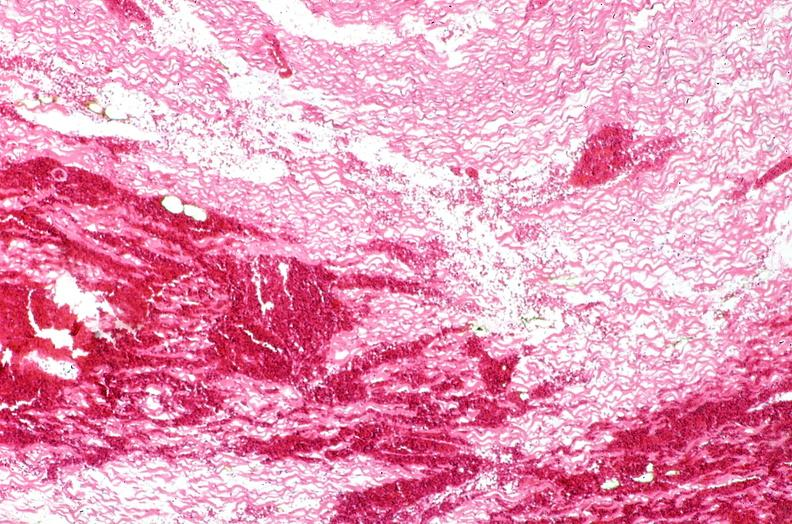what is present?
Answer the question using a single word or phrase. Heart 